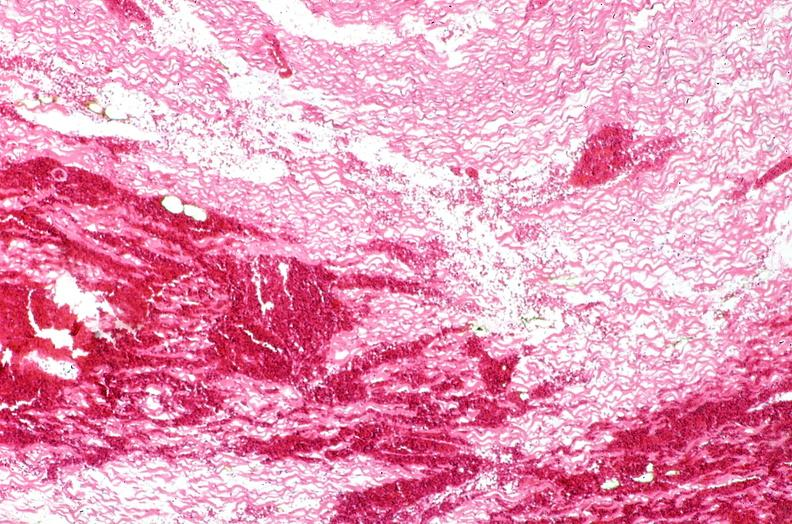what is present?
Answer the question using a single word or phrase. Heart 